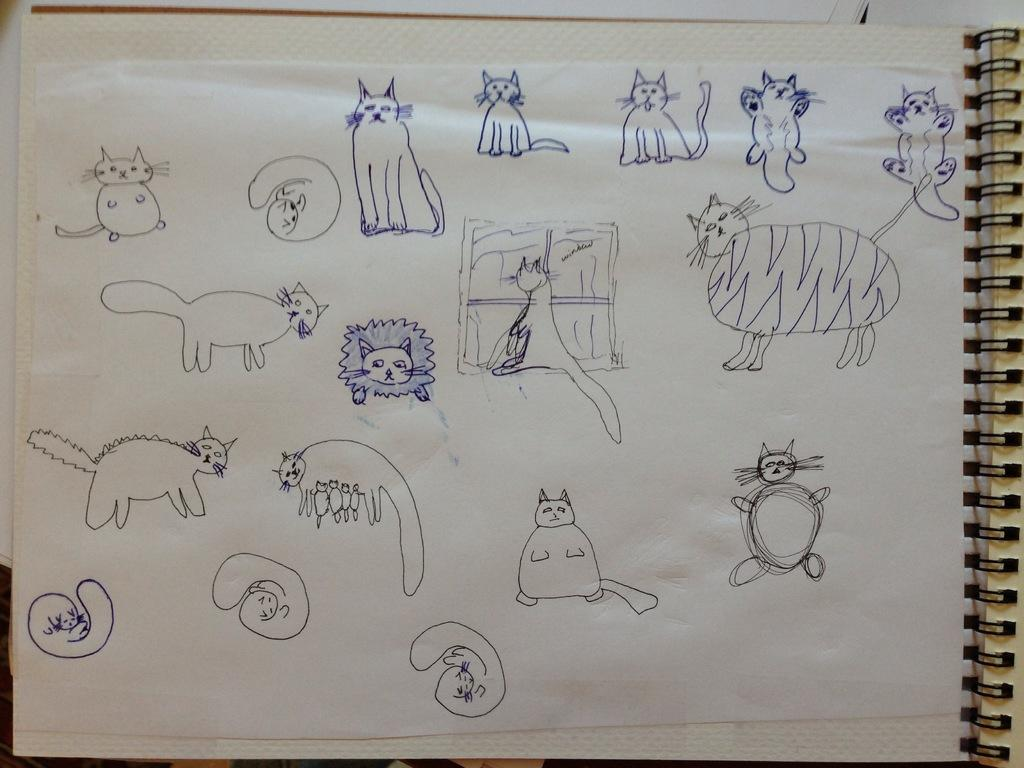What is present in the image that has drawings on it? There is a paper in the image that has various cat images drawn on it. What type of drawing tool was used to create the cat images? The cat images are drawn using a pen. Where is the fireman located in the image? There is no fireman present in the image. What type of jewelry is the cat wearing in the image? The cat images are drawings on a paper and do not have any jewelry, such as rings. 